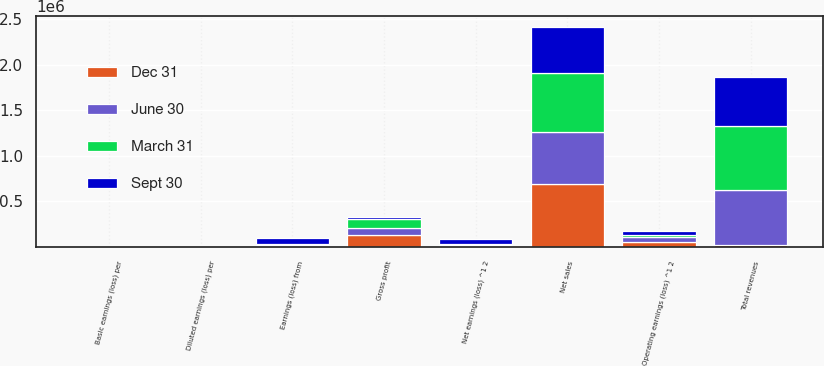Convert chart to OTSL. <chart><loc_0><loc_0><loc_500><loc_500><stacked_bar_chart><ecel><fcel>Net sales<fcel>Total revenues<fcel>Gross profit<fcel>Operating earnings (loss) ^1 2<fcel>Earnings (loss) from<fcel>Net earnings (loss) ^1 2<fcel>Basic earnings (loss) per<fcel>Diluted earnings (loss) per<nl><fcel>Sept 30<fcel>499851<fcel>535882<fcel>21958<fcel>46279<fcel>57050<fcel>52053<fcel>0.44<fcel>0.44<nl><fcel>March 31<fcel>648890<fcel>694136<fcel>105939<fcel>19662<fcel>16985<fcel>18283<fcel>0.13<fcel>0.13<nl><fcel>Dec 31<fcel>687616<fcel>21958<fcel>126923<fcel>55866<fcel>15621<fcel>14260<fcel>0.12<fcel>0.12<nl><fcel>June 30<fcel>574886<fcel>608431<fcel>79206<fcel>55532<fcel>4488<fcel>3483<fcel>0.03<fcel>0.03<nl></chart> 